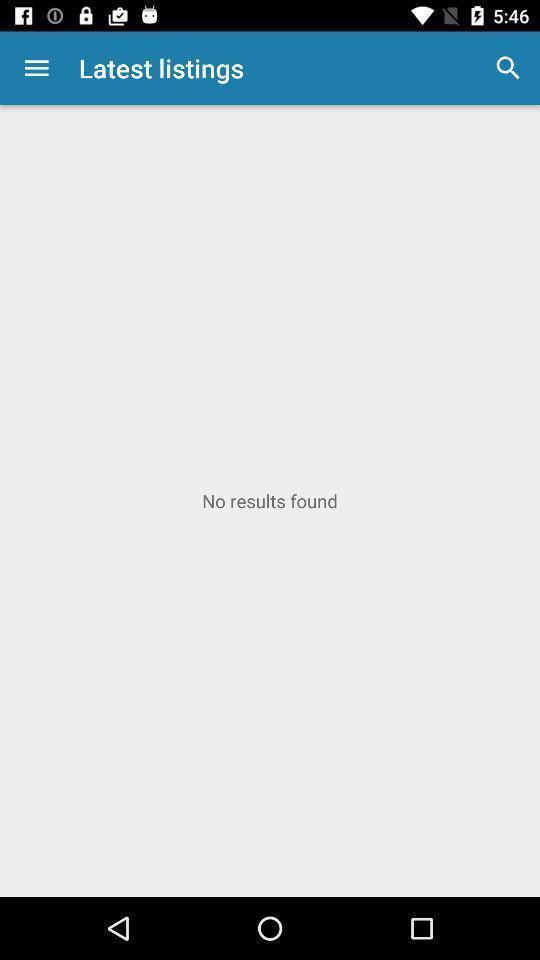Explain the elements present in this screenshot. Search page. 